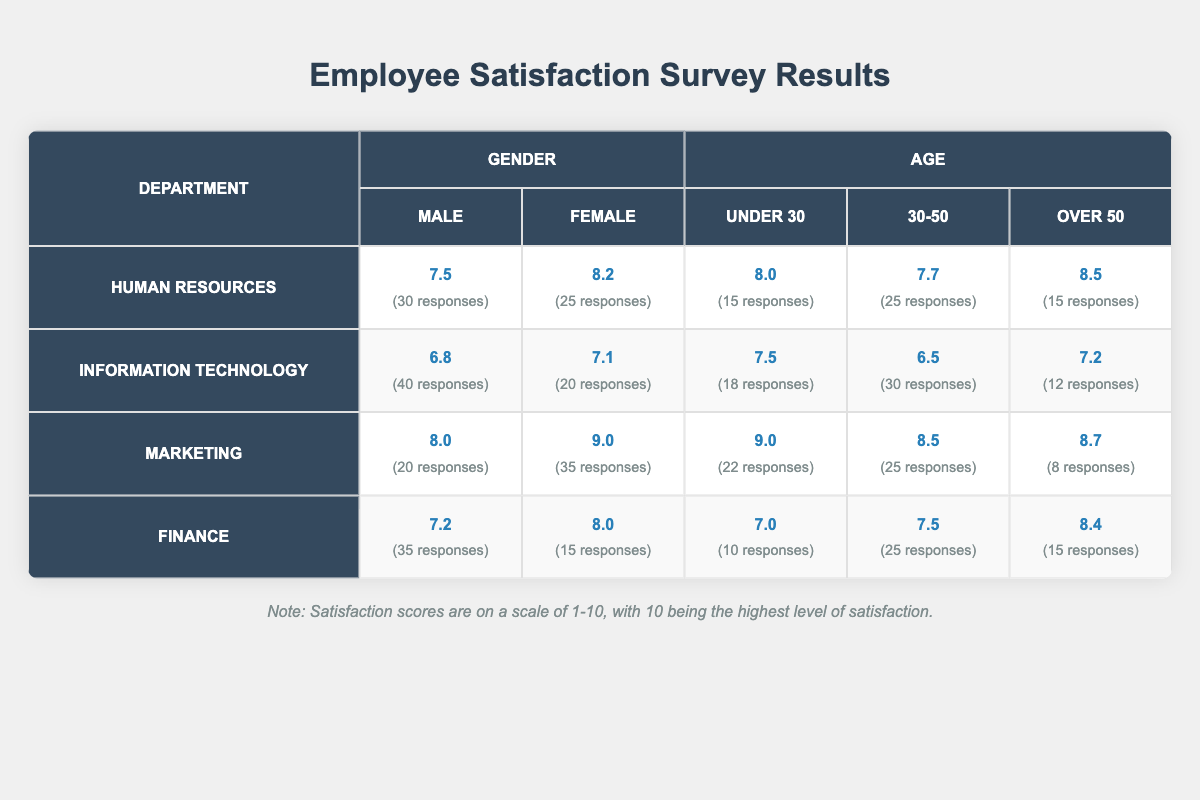What is the satisfaction score for males in the Marketing department? The table shows that the satisfaction score for males in the Marketing department is listed under the Gender category. Specifically, it is 8.0.
Answer: 8.0 What is the response count for females in the Human Resources department? The table indicates that the response count for females in the Human Resources department is 25, as noted next to the satisfaction score of 8.2.
Answer: 25 Which department has the highest satisfaction score for individuals over 50? By comparing the satisfaction scores for the Over 50 category across all departments, Marketing has the highest score of 8.7, surpassing the others listed.
Answer: Marketing How many total responses were collected for the Information Technology department? The total responses for the Information Technology department can be calculated by adding the response counts for males (40) and females (20), as well as the responses in each age group (18 for Under 30, 30 for 30-50, and 12 for Over 50). Thus, the total is 40 + 20 + 18 + 30 + 12 = 130.
Answer: 130 Is the satisfaction score for males in the Finance department higher than the score for females in the same department? The satisfaction score for males in the Finance department is 7.2, while for females, it is 8.0. Since 7.2 is less than 8.0, the answer is no.
Answer: No What is the average satisfaction score for females across all departments? To find the average satisfaction score for females, we sum their scores: Human Resources (8.2) + Information Technology (7.1) + Marketing (9.0) + Finance (8.0) = 32.3. The total number of female responses is 25 + 20 + 35 + 15 = 95. The average is 32.3/4 = 8.075.
Answer: 8.075 Which demographic group in the Human Resources department reported the highest satisfaction score? In the Human Resources department, the Over 50 age group has the highest satisfaction score of 8.5 when compared to other gender and age demographics.
Answer: Over 50 What is the difference in satisfaction scores between the youngest (Under 30) and oldest (Over 50) demographics in the Finance department? For the Finance department, the satisfaction score for Under 30 is 7.0, and for Over 50, it is 8.4. The difference is 8.4 - 7.0 = 1.4.
Answer: 1.4 How many responses did males in the Information Technology department give compared to females? Males in the Information Technology department gave 40 responses while females gave 20 responses. Thus, there are 40 responses from males and 20 from females, indicating males provided more responses.
Answer: Males provided more responses 